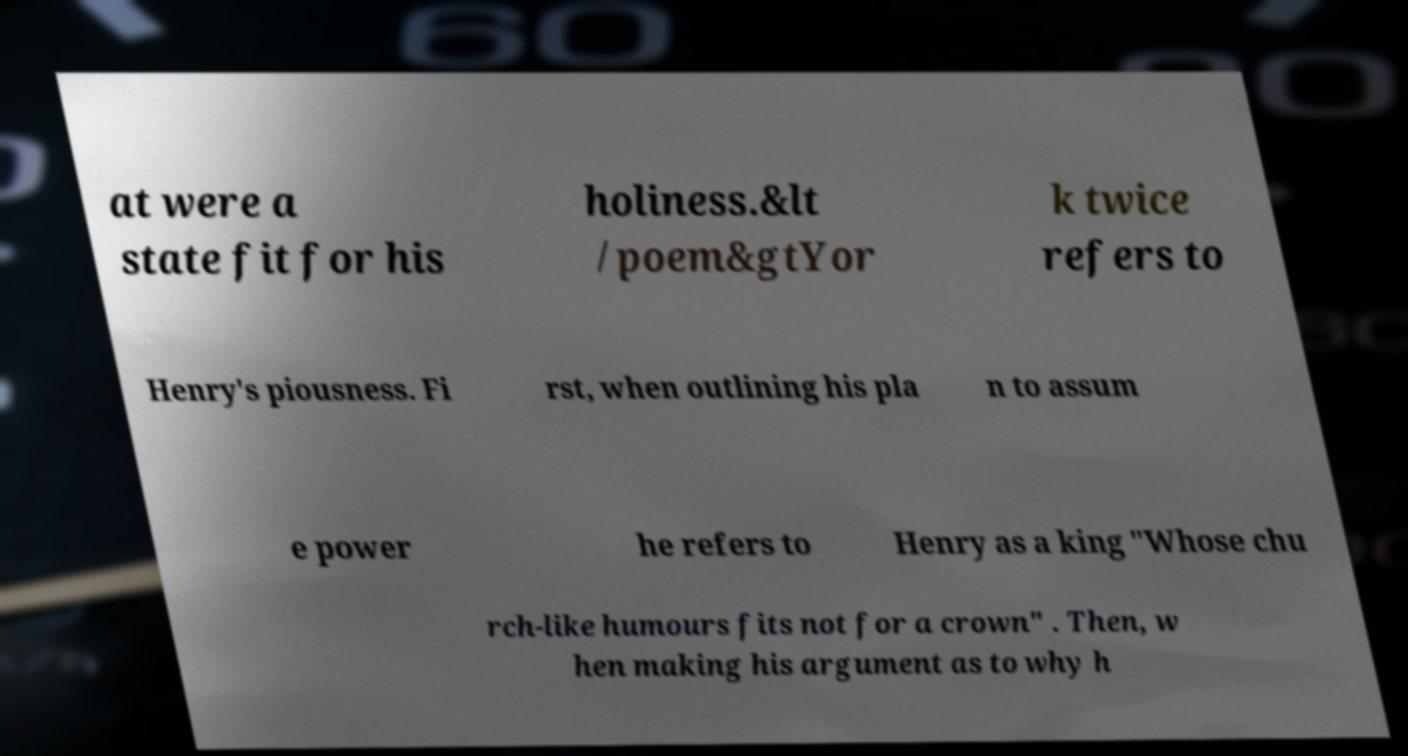Could you extract and type out the text from this image? at were a state fit for his holiness.&lt /poem&gtYor k twice refers to Henry's piousness. Fi rst, when outlining his pla n to assum e power he refers to Henry as a king "Whose chu rch-like humours fits not for a crown" . Then, w hen making his argument as to why h 